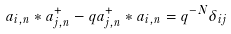<formula> <loc_0><loc_0><loc_500><loc_500>a _ { i , n } * a _ { j , n } ^ { + } - q a _ { j , n } ^ { + } * a _ { i , n } = q ^ { - N } \delta _ { i j }</formula> 